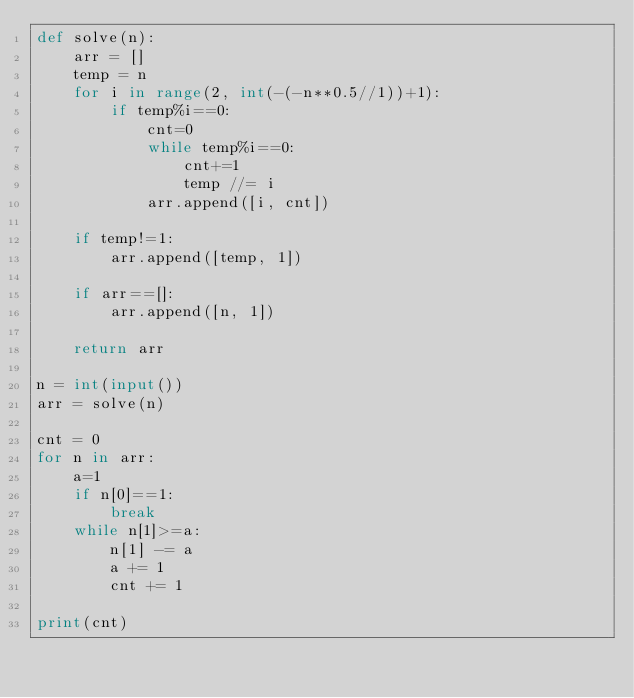Convert code to text. <code><loc_0><loc_0><loc_500><loc_500><_Python_>def solve(n):
    arr = []
    temp = n
    for i in range(2, int(-(-n**0.5//1))+1):
        if temp%i==0:
            cnt=0
            while temp%i==0:
                cnt+=1
                temp //= i
            arr.append([i, cnt])

    if temp!=1:
        arr.append([temp, 1])

    if arr==[]:
        arr.append([n, 1])

    return arr

n = int(input())
arr = solve(n)

cnt = 0
for n in arr:
    a=1
    if n[0]==1:
        break
    while n[1]>=a:
        n[1] -= a
        a += 1
        cnt += 1

print(cnt)</code> 